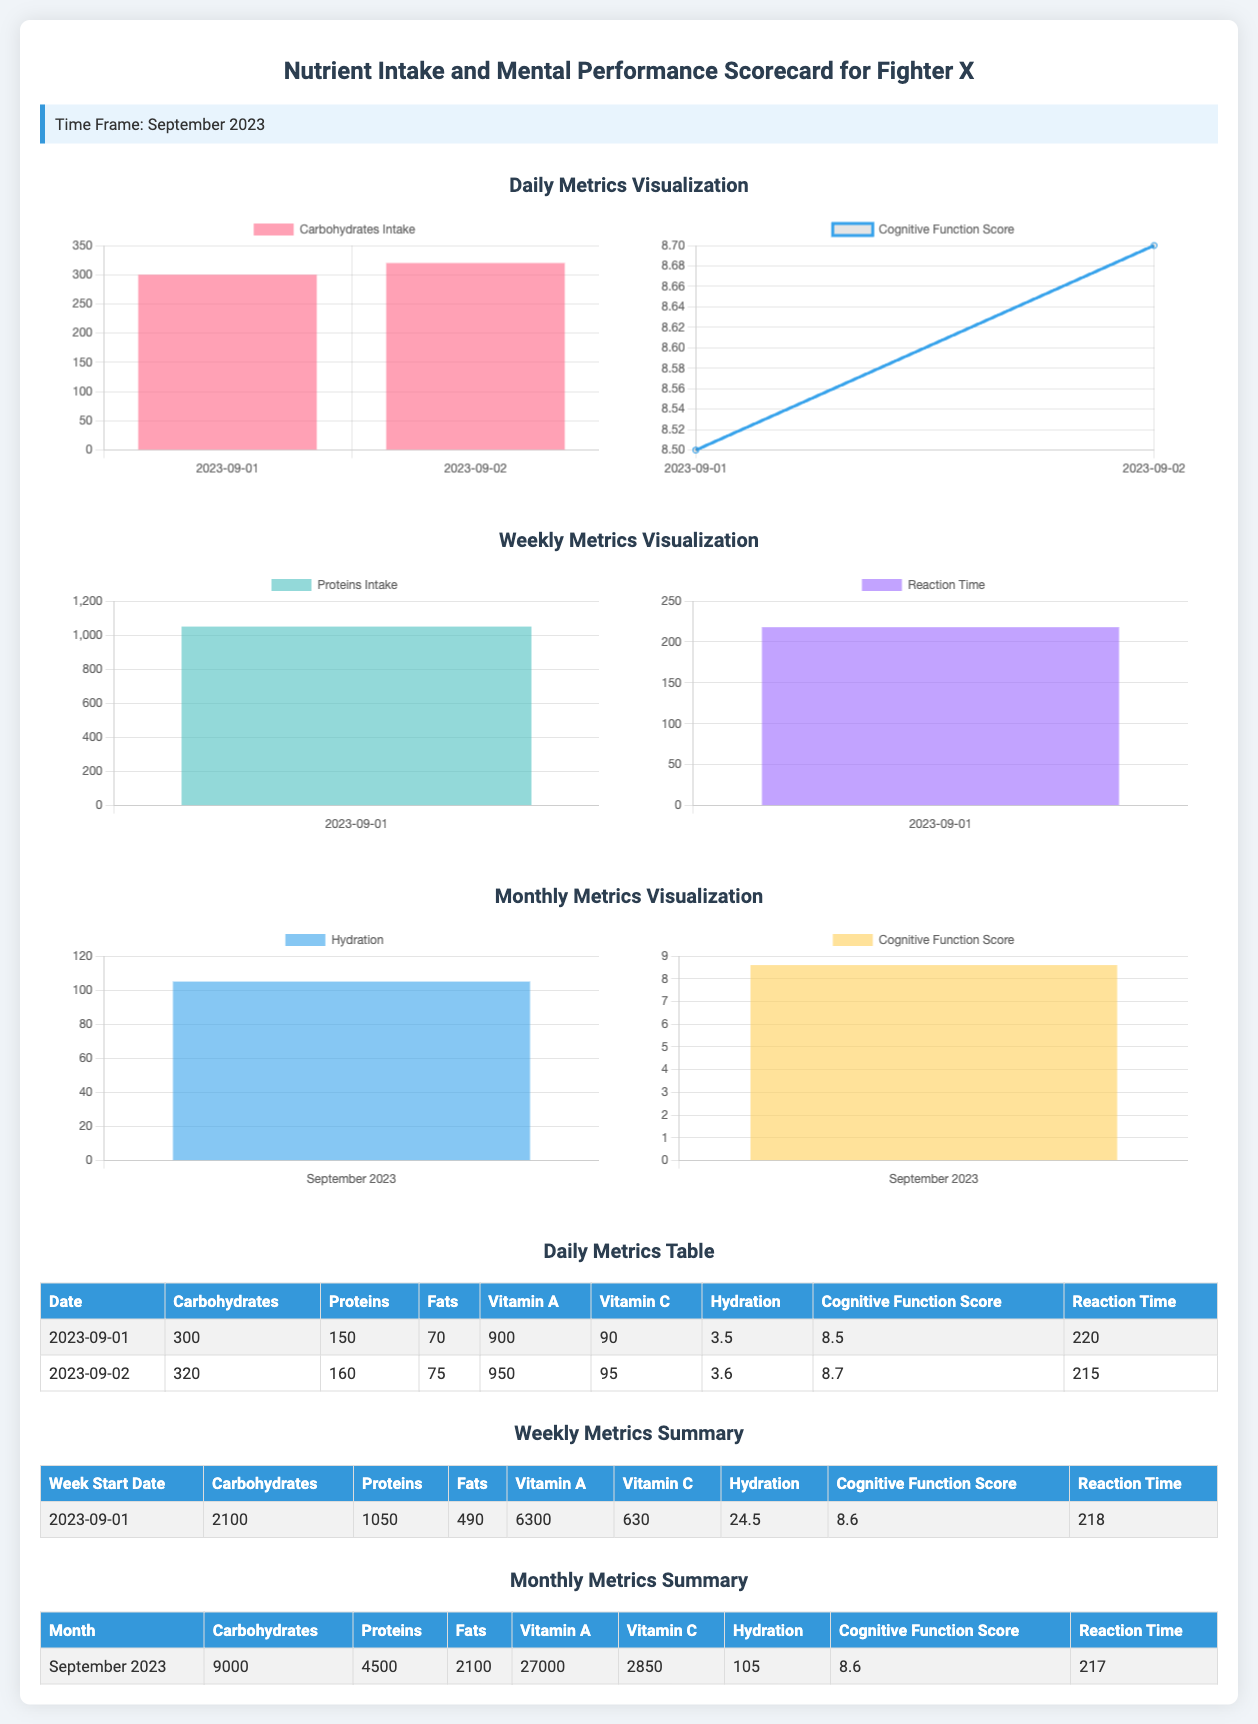What was Fighter X's carbohydrate intake on September 1, 2023? The carbohydrate intake for September 1, 2023, is listed directly in the daily metrics table.
Answer: 300 What is the average cognitive function score for September 2023? The average cognitive function score is reported in the monthly metrics summary table as a single number.
Answer: 8.6 What was the reaction time recorded on September 2, 2023? Reaction time can be found in the daily metrics table under the respective date.
Answer: 215 How many grams of protein did Fighter X consume during the week starting September 1, 2023? The weekly intake of protein is summarized in the weekly metrics summary table.
Answer: 1050 What is the hydration level for the month of September 2023? The monthly hydration level is stated in the monthly metrics summary table as a single value.
Answer: 105 How does Fighter X's cognitive function score trend from September 1 to September 2, 2023? The cognitive function scores for these dates can be compared using the daily mental performance chart, which shows values for both dates.
Answer: Increasing What nutrient intake was highest on September 2, 2023? Nutrient intake comparisons can be found in the daily metrics table, showing that carbohydrates were the highest on September 2, 2023.
Answer: Carbohydrates How many days of data are presented in the daily metrics table? The daily metrics table contains a specific count of the dates listed, which indicates the amount of data.
Answer: 2 What is the total fat intake for the month of September 2023? The total fat intake is provided in the monthly metrics summary table.
Answer: 2100 